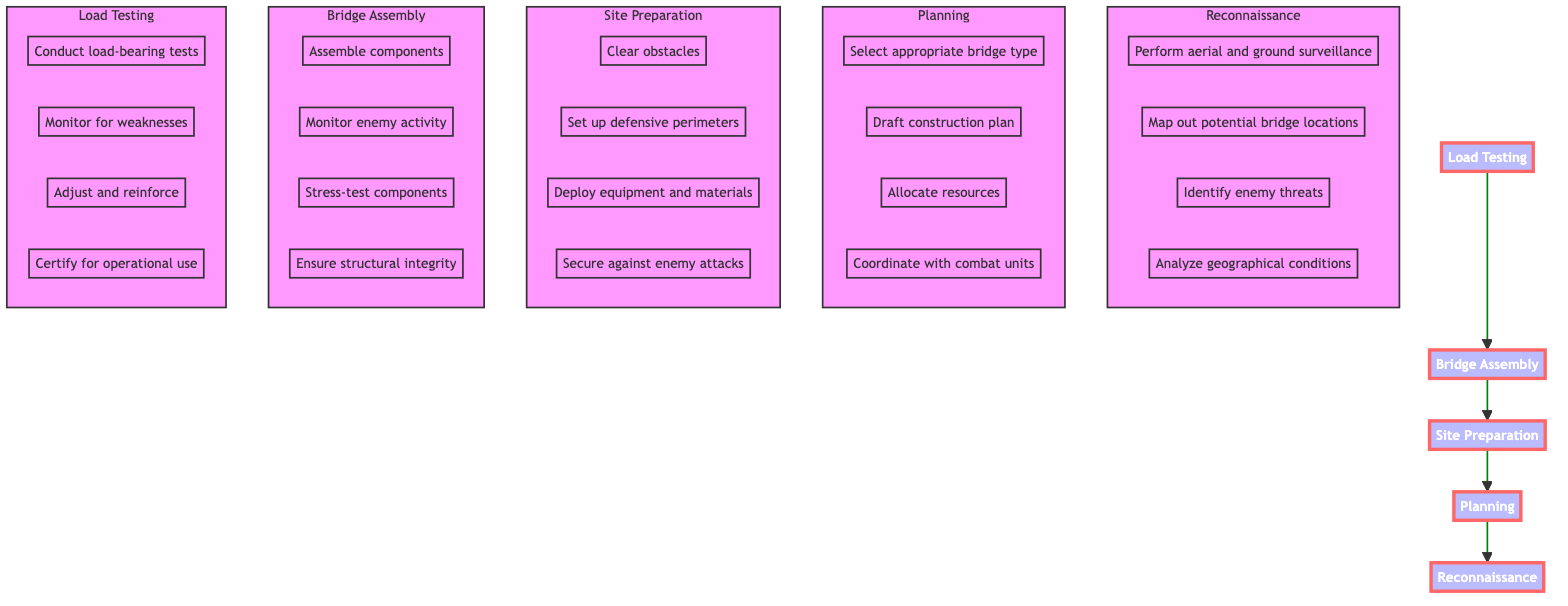What is the first step in the bridge construction process? The diagram shows that the first step in the bridge construction process is labeled "Reconnaissance," which occurs at the bottom of the flowchart.
Answer: Reconnaissance How many main steps are there in the process? Counting the main steps listed in the flowchart, there are five steps: Reconnaissance, Planning, Site Preparation, Bridge Assembly, and Load Testing.
Answer: Five What follows Site Preparation in the process? According to the flowchart, after Site Preparation, the next step is Bridge Assembly, indicating the flow of the construction process moves upward from Site Preparation to Bridge Assembly.
Answer: Bridge Assembly What type of bridge can be selected in the Planning phase? The flowchart details that during the Planning phase, one can select a bridge type such as Bailey, Ribbon, or Pontoon, indicating various options are available based on the construction needs.
Answer: Bailey, Ribbon, Pontoon What is the last task in the Load Testing phase? In the Load Testing phase, the flowchart states that the final task is to "Certify the bridge for operational use," marking it as the concluding step in the load testing process.
Answer: Certify the bridge for operational use How many tasks are involved in the Bridge Assembly phase? The flowchart indicates that there are four tasks involved in the Bridge Assembly phase: Assemble components, Monitor enemy activity, Stress-test components, and Ensure structural integrity, which can be counted from the provided details.
Answer: Four Which phased task involves securing the construction site against enemy attacks? The flowchart specifies that "Secure against enemy attacks" is a task listed in the Site Preparation phase, highlighting an essential security measure during that stage.
Answer: Secure against enemy attacks What are the bridge types mentioned in the Planning step? The flowchart provides information that during the Planning step, the bridge types mentioned include Bailey, Ribbon, and Pontoon, which reflect the different construction options in hostile environments.
Answer: Bailey, Ribbon, Pontoon Which step is responsible for ensuring structural integrity? The flowchart demonstrates that ensuring structural integrity occurs in the Bridge Assembly step as one of the tasks under that phase, indicating that maintaining strength throughout construction is a key focus.
Answer: Bridge Assembly 